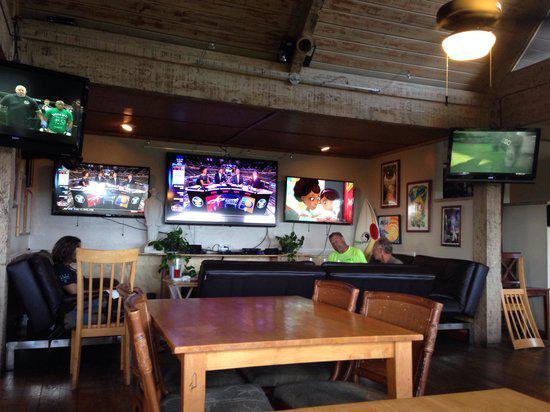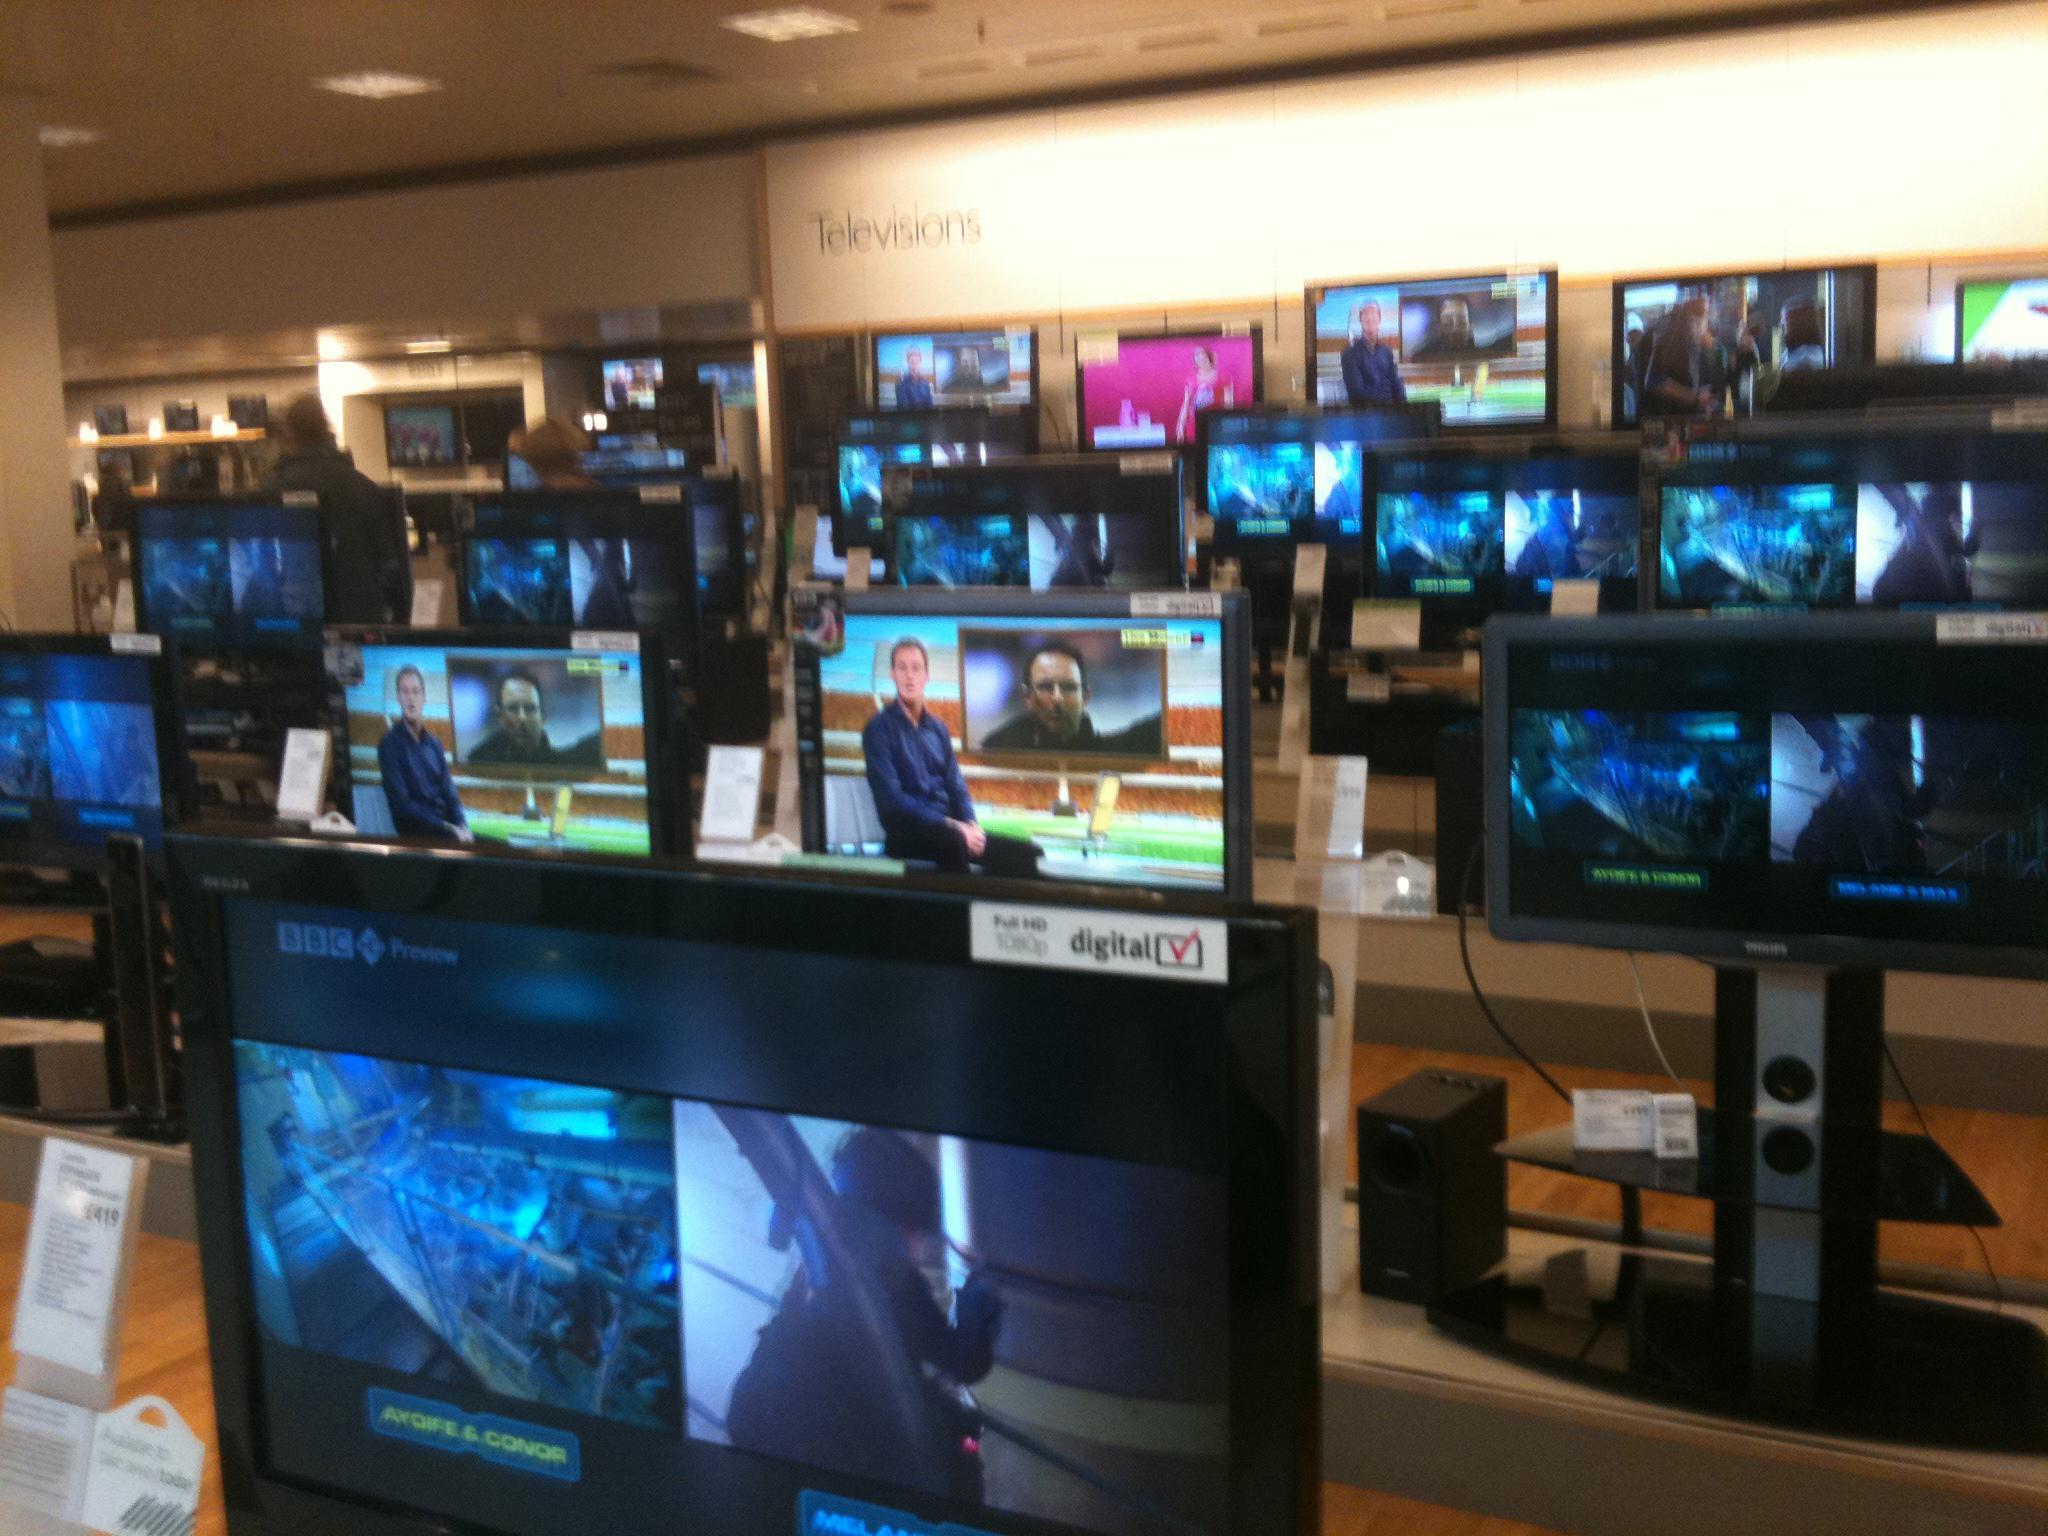The first image is the image on the left, the second image is the image on the right. Given the left and right images, does the statement "In one image, the screens are in a store setting." hold true? Answer yes or no. Yes. 